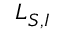<formula> <loc_0><loc_0><loc_500><loc_500>L _ { S , I }</formula> 